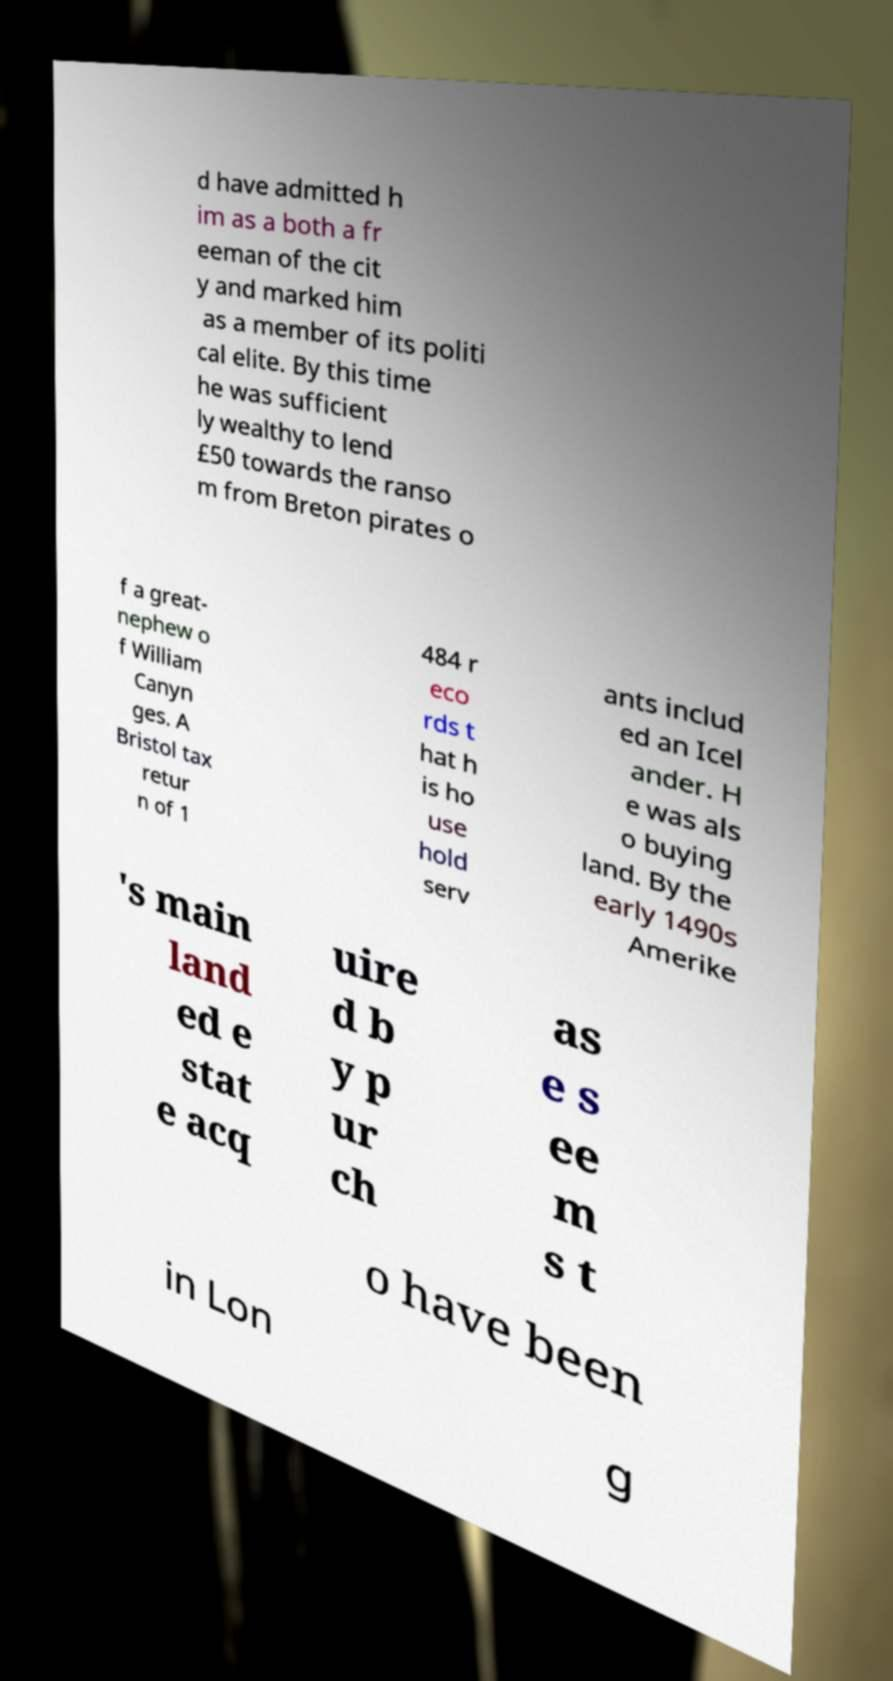Can you read and provide the text displayed in the image?This photo seems to have some interesting text. Can you extract and type it out for me? d have admitted h im as a both a fr eeman of the cit y and marked him as a member of its politi cal elite. By this time he was sufficient ly wealthy to lend £50 towards the ranso m from Breton pirates o f a great- nephew o f William Canyn ges. A Bristol tax retur n of 1 484 r eco rds t hat h is ho use hold serv ants includ ed an Icel ander. H e was als o buying land. By the early 1490s Amerike 's main land ed e stat e acq uire d b y p ur ch as e s ee m s t o have been in Lon g 